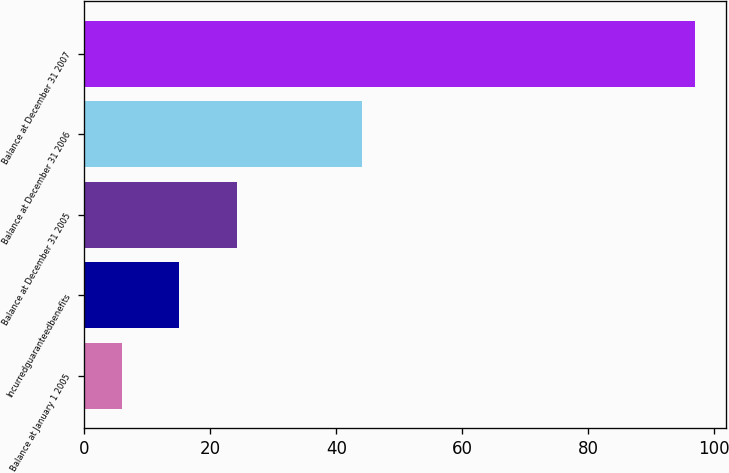<chart> <loc_0><loc_0><loc_500><loc_500><bar_chart><fcel>Balance at January 1 2005<fcel>Incurredguaranteedbenefits<fcel>Balance at December 31 2005<fcel>Balance at December 31 2006<fcel>Balance at December 31 2007<nl><fcel>6<fcel>15.1<fcel>24.2<fcel>44<fcel>97<nl></chart> 